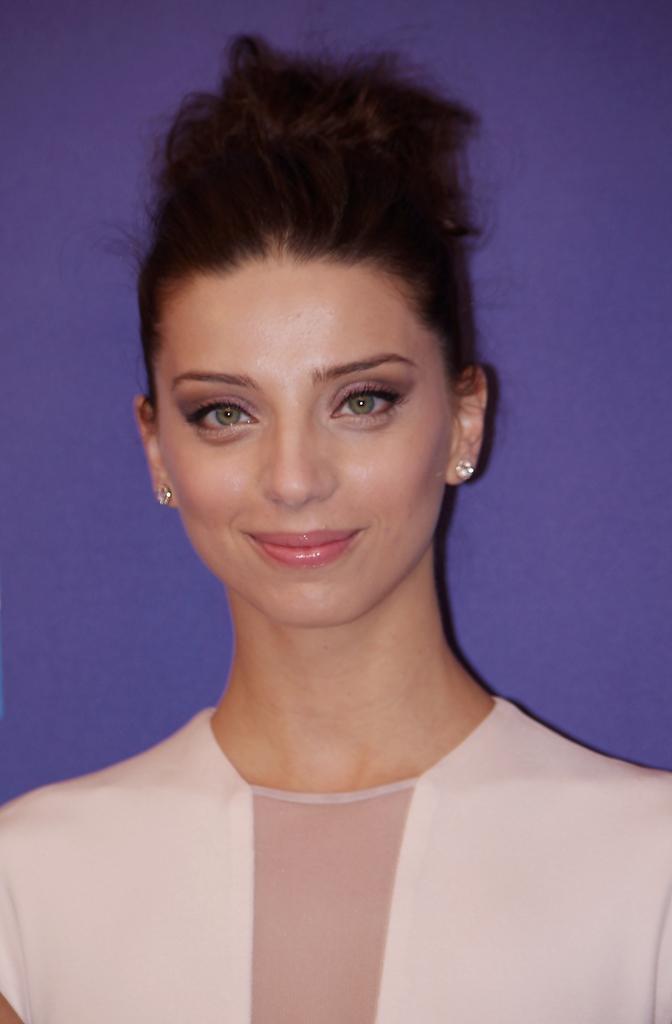In one or two sentences, can you explain what this image depicts? In this picture there is a lady in the center of the image. 